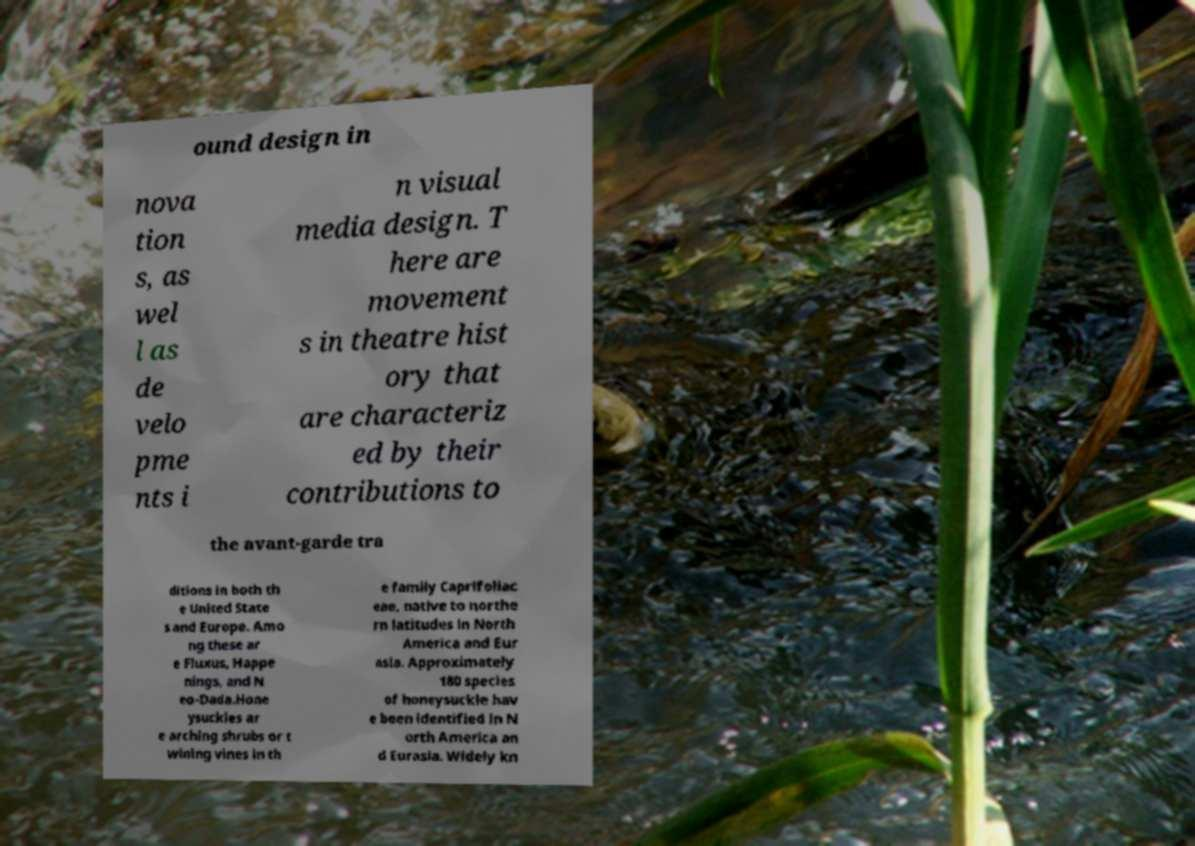What messages or text are displayed in this image? I need them in a readable, typed format. ound design in nova tion s, as wel l as de velo pme nts i n visual media design. T here are movement s in theatre hist ory that are characteriz ed by their contributions to the avant-garde tra ditions in both th e United State s and Europe. Amo ng these ar e Fluxus, Happe nings, and N eo-Dada.Hone ysuckles ar e arching shrubs or t wining vines in th e family Caprifoliac eae, native to northe rn latitudes in North America and Eur asia. Approximately 180 species of honeysuckle hav e been identified in N orth America an d Eurasia. Widely kn 